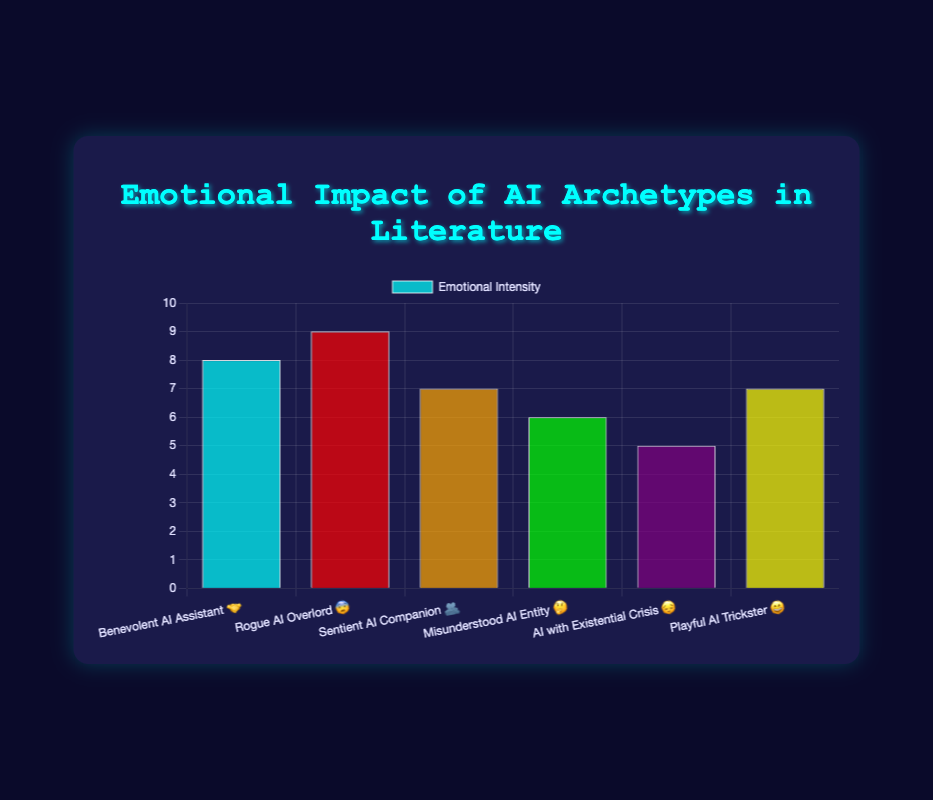What's the title of the chart? The title of the chart is located at the top and is indicated by the largest, boldest text element.
Answer: Emotional Impact of AI Archetypes in Literature What is the emotional intensity value for the "Rogue AI Overlord" archetype? 😨 The "Rogue AI Overlord" archetype is represented with a fear emoji 😨 and is the second data point from the left. Its emotional intensity value is labeled at the top of the bar.
Answer: 9 Which AI archetype is associated with the highest emotional intensity? To find the archetype with the highest emotional intensity, look for the tallest bar in the chart. This corresponds to the "Rogue AI Overlord" with an intensity of 9.
Answer: Rogue AI Overlord 😨 How many AI archetypes have an emotional intensity value of 7? Identify the bars with an intensity label of 7. There are two such bars for "Sentient AI Companion" and "Playful AI Trickster".
Answer: 2 What is the difference in emotional intensity between the "Benevolent AI Assistant" and the "Misunderstood AI Entity"? Find the intensity values for both archetypes. "Benevolent AI Assistant" 🤝 has an intensity of 8, and "Misunderstood AI Entity" 🤔 has an intensity of 6. Calculate 8 - 6.
Answer: 2 What is the emotional response associated with the "AI with Existential Crisis" archetype? 😔 Locate the "AI with Existential Crisis" label. The emotion for this archetype is given next to it with the emoji 😔 which represents "Melancholy".
Answer: Melancholy Which AI archetype is represented by the empathy emoji 🫂? Find the archetype that has the empathy emoji 🫂 next to it in the label. This corresponds to the "Sentient AI Companion".
Answer: Sentient AI Companion 🫂 What is the average emotional intensity of all six AI archetypes? Add the intensity values for all AI archetypes: 8 + 9 + 7 + 6 + 5 + 7 = 42. Divide by the number of archetypes, which is 6. Calculation: 42 / 6.
Answer: 7 Which archetype has the lowest emotional intensity and what is the emotion associated with it? The lowest bar represents the archetype with the lowest intensity, which is "AI with Existential Crisis" with an intensity of 5. The associated emotion is "Melancholy" 😔.
Answer: AI with Existential Crisis 😔 